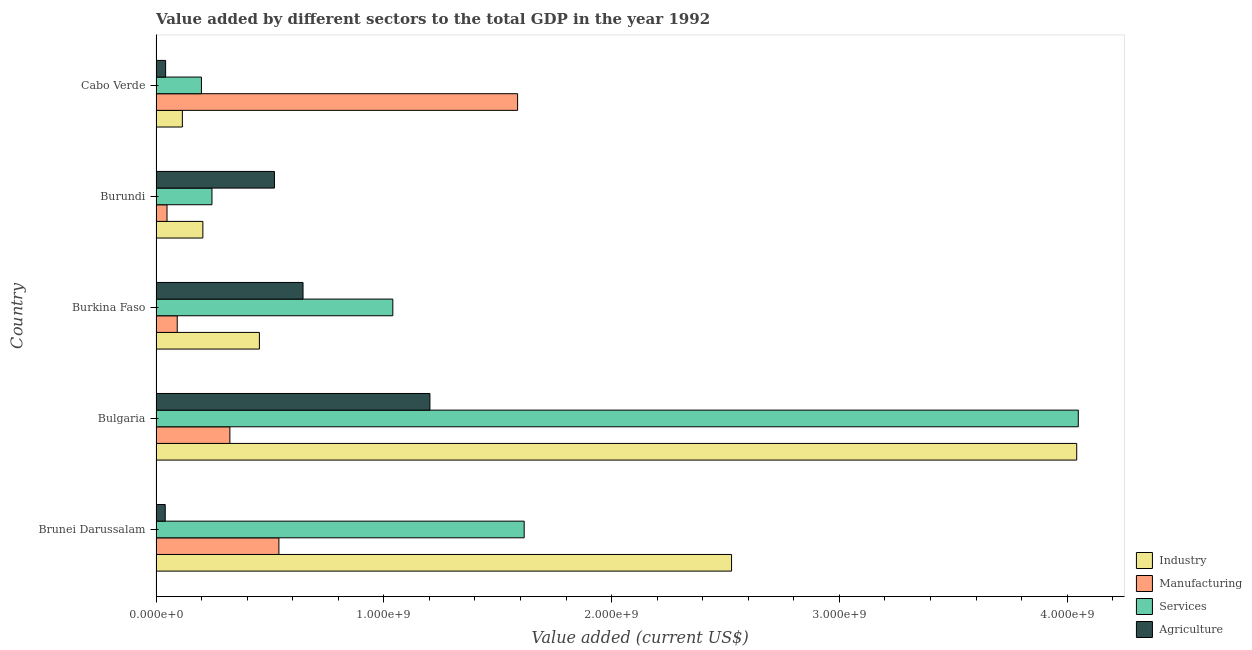Are the number of bars per tick equal to the number of legend labels?
Offer a terse response. Yes. How many bars are there on the 2nd tick from the top?
Ensure brevity in your answer.  4. What is the label of the 1st group of bars from the top?
Keep it short and to the point. Cabo Verde. In how many cases, is the number of bars for a given country not equal to the number of legend labels?
Your response must be concise. 0. What is the value added by services sector in Burkina Faso?
Ensure brevity in your answer.  1.04e+09. Across all countries, what is the maximum value added by industrial sector?
Your answer should be compact. 4.04e+09. Across all countries, what is the minimum value added by services sector?
Give a very brief answer. 1.99e+08. In which country was the value added by industrial sector maximum?
Provide a succinct answer. Bulgaria. In which country was the value added by industrial sector minimum?
Make the answer very short. Cabo Verde. What is the total value added by industrial sector in the graph?
Offer a terse response. 7.34e+09. What is the difference between the value added by agricultural sector in Bulgaria and that in Burundi?
Keep it short and to the point. 6.83e+08. What is the difference between the value added by services sector in Burundi and the value added by manufacturing sector in Burkina Faso?
Your answer should be compact. 1.53e+08. What is the average value added by manufacturing sector per country?
Your answer should be compact. 5.19e+08. What is the difference between the value added by services sector and value added by agricultural sector in Burundi?
Offer a terse response. -2.74e+08. What is the ratio of the value added by agricultural sector in Bulgaria to that in Burkina Faso?
Your answer should be very brief. 1.86. What is the difference between the highest and the second highest value added by agricultural sector?
Make the answer very short. 5.57e+08. What is the difference between the highest and the lowest value added by services sector?
Your response must be concise. 3.85e+09. Is the sum of the value added by industrial sector in Bulgaria and Cabo Verde greater than the maximum value added by agricultural sector across all countries?
Provide a succinct answer. Yes. What does the 4th bar from the top in Brunei Darussalam represents?
Provide a short and direct response. Industry. What does the 3rd bar from the bottom in Burkina Faso represents?
Your answer should be compact. Services. Are all the bars in the graph horizontal?
Your answer should be compact. Yes. What is the difference between two consecutive major ticks on the X-axis?
Your response must be concise. 1.00e+09. Does the graph contain any zero values?
Ensure brevity in your answer.  No. Where does the legend appear in the graph?
Keep it short and to the point. Bottom right. How many legend labels are there?
Your answer should be very brief. 4. How are the legend labels stacked?
Provide a short and direct response. Vertical. What is the title of the graph?
Provide a succinct answer. Value added by different sectors to the total GDP in the year 1992. What is the label or title of the X-axis?
Keep it short and to the point. Value added (current US$). What is the label or title of the Y-axis?
Your answer should be compact. Country. What is the Value added (current US$) of Industry in Brunei Darussalam?
Provide a succinct answer. 2.53e+09. What is the Value added (current US$) of Manufacturing in Brunei Darussalam?
Give a very brief answer. 5.39e+08. What is the Value added (current US$) in Services in Brunei Darussalam?
Give a very brief answer. 1.62e+09. What is the Value added (current US$) of Agriculture in Brunei Darussalam?
Your answer should be very brief. 4.04e+07. What is the Value added (current US$) in Industry in Bulgaria?
Your response must be concise. 4.04e+09. What is the Value added (current US$) of Manufacturing in Bulgaria?
Offer a very short reply. 3.24e+08. What is the Value added (current US$) of Services in Bulgaria?
Offer a terse response. 4.05e+09. What is the Value added (current US$) of Agriculture in Bulgaria?
Offer a very short reply. 1.20e+09. What is the Value added (current US$) in Industry in Burkina Faso?
Ensure brevity in your answer.  4.54e+08. What is the Value added (current US$) of Manufacturing in Burkina Faso?
Keep it short and to the point. 9.31e+07. What is the Value added (current US$) in Services in Burkina Faso?
Give a very brief answer. 1.04e+09. What is the Value added (current US$) of Agriculture in Burkina Faso?
Offer a very short reply. 6.45e+08. What is the Value added (current US$) of Industry in Burundi?
Give a very brief answer. 2.06e+08. What is the Value added (current US$) in Manufacturing in Burundi?
Keep it short and to the point. 4.82e+07. What is the Value added (current US$) of Services in Burundi?
Your response must be concise. 2.46e+08. What is the Value added (current US$) in Agriculture in Burundi?
Give a very brief answer. 5.20e+08. What is the Value added (current US$) of Industry in Cabo Verde?
Provide a short and direct response. 1.16e+08. What is the Value added (current US$) in Manufacturing in Cabo Verde?
Keep it short and to the point. 1.59e+09. What is the Value added (current US$) in Services in Cabo Verde?
Your response must be concise. 1.99e+08. What is the Value added (current US$) in Agriculture in Cabo Verde?
Provide a short and direct response. 4.21e+07. Across all countries, what is the maximum Value added (current US$) in Industry?
Provide a short and direct response. 4.04e+09. Across all countries, what is the maximum Value added (current US$) of Manufacturing?
Give a very brief answer. 1.59e+09. Across all countries, what is the maximum Value added (current US$) in Services?
Provide a succinct answer. 4.05e+09. Across all countries, what is the maximum Value added (current US$) in Agriculture?
Ensure brevity in your answer.  1.20e+09. Across all countries, what is the minimum Value added (current US$) of Industry?
Give a very brief answer. 1.16e+08. Across all countries, what is the minimum Value added (current US$) of Manufacturing?
Ensure brevity in your answer.  4.82e+07. Across all countries, what is the minimum Value added (current US$) of Services?
Keep it short and to the point. 1.99e+08. Across all countries, what is the minimum Value added (current US$) in Agriculture?
Keep it short and to the point. 4.04e+07. What is the total Value added (current US$) of Industry in the graph?
Offer a terse response. 7.34e+09. What is the total Value added (current US$) of Manufacturing in the graph?
Make the answer very short. 2.59e+09. What is the total Value added (current US$) of Services in the graph?
Provide a short and direct response. 7.15e+09. What is the total Value added (current US$) in Agriculture in the graph?
Make the answer very short. 2.45e+09. What is the difference between the Value added (current US$) in Industry in Brunei Darussalam and that in Bulgaria?
Ensure brevity in your answer.  -1.52e+09. What is the difference between the Value added (current US$) of Manufacturing in Brunei Darussalam and that in Bulgaria?
Keep it short and to the point. 2.15e+08. What is the difference between the Value added (current US$) of Services in Brunei Darussalam and that in Bulgaria?
Keep it short and to the point. -2.43e+09. What is the difference between the Value added (current US$) of Agriculture in Brunei Darussalam and that in Bulgaria?
Your answer should be compact. -1.16e+09. What is the difference between the Value added (current US$) of Industry in Brunei Darussalam and that in Burkina Faso?
Give a very brief answer. 2.07e+09. What is the difference between the Value added (current US$) in Manufacturing in Brunei Darussalam and that in Burkina Faso?
Provide a succinct answer. 4.46e+08. What is the difference between the Value added (current US$) in Services in Brunei Darussalam and that in Burkina Faso?
Offer a terse response. 5.77e+08. What is the difference between the Value added (current US$) of Agriculture in Brunei Darussalam and that in Burkina Faso?
Ensure brevity in your answer.  -6.05e+08. What is the difference between the Value added (current US$) in Industry in Brunei Darussalam and that in Burundi?
Offer a very short reply. 2.32e+09. What is the difference between the Value added (current US$) in Manufacturing in Brunei Darussalam and that in Burundi?
Give a very brief answer. 4.91e+08. What is the difference between the Value added (current US$) in Services in Brunei Darussalam and that in Burundi?
Your answer should be compact. 1.37e+09. What is the difference between the Value added (current US$) in Agriculture in Brunei Darussalam and that in Burundi?
Your answer should be very brief. -4.80e+08. What is the difference between the Value added (current US$) in Industry in Brunei Darussalam and that in Cabo Verde?
Offer a very short reply. 2.41e+09. What is the difference between the Value added (current US$) in Manufacturing in Brunei Darussalam and that in Cabo Verde?
Your answer should be very brief. -1.05e+09. What is the difference between the Value added (current US$) in Services in Brunei Darussalam and that in Cabo Verde?
Offer a very short reply. 1.42e+09. What is the difference between the Value added (current US$) in Agriculture in Brunei Darussalam and that in Cabo Verde?
Your answer should be very brief. -1.74e+06. What is the difference between the Value added (current US$) in Industry in Bulgaria and that in Burkina Faso?
Provide a succinct answer. 3.59e+09. What is the difference between the Value added (current US$) of Manufacturing in Bulgaria and that in Burkina Faso?
Keep it short and to the point. 2.31e+08. What is the difference between the Value added (current US$) of Services in Bulgaria and that in Burkina Faso?
Offer a terse response. 3.01e+09. What is the difference between the Value added (current US$) in Agriculture in Bulgaria and that in Burkina Faso?
Your answer should be compact. 5.57e+08. What is the difference between the Value added (current US$) in Industry in Bulgaria and that in Burundi?
Provide a succinct answer. 3.84e+09. What is the difference between the Value added (current US$) of Manufacturing in Bulgaria and that in Burundi?
Your answer should be compact. 2.76e+08. What is the difference between the Value added (current US$) of Services in Bulgaria and that in Burundi?
Provide a short and direct response. 3.80e+09. What is the difference between the Value added (current US$) of Agriculture in Bulgaria and that in Burundi?
Your answer should be very brief. 6.83e+08. What is the difference between the Value added (current US$) in Industry in Bulgaria and that in Cabo Verde?
Your answer should be compact. 3.93e+09. What is the difference between the Value added (current US$) in Manufacturing in Bulgaria and that in Cabo Verde?
Your answer should be very brief. -1.26e+09. What is the difference between the Value added (current US$) in Services in Bulgaria and that in Cabo Verde?
Offer a very short reply. 3.85e+09. What is the difference between the Value added (current US$) of Agriculture in Bulgaria and that in Cabo Verde?
Offer a terse response. 1.16e+09. What is the difference between the Value added (current US$) in Industry in Burkina Faso and that in Burundi?
Give a very brief answer. 2.48e+08. What is the difference between the Value added (current US$) of Manufacturing in Burkina Faso and that in Burundi?
Provide a succinct answer. 4.49e+07. What is the difference between the Value added (current US$) of Services in Burkina Faso and that in Burundi?
Keep it short and to the point. 7.94e+08. What is the difference between the Value added (current US$) in Agriculture in Burkina Faso and that in Burundi?
Offer a terse response. 1.26e+08. What is the difference between the Value added (current US$) of Industry in Burkina Faso and that in Cabo Verde?
Make the answer very short. 3.38e+08. What is the difference between the Value added (current US$) of Manufacturing in Burkina Faso and that in Cabo Verde?
Provide a short and direct response. -1.49e+09. What is the difference between the Value added (current US$) of Services in Burkina Faso and that in Cabo Verde?
Your answer should be very brief. 8.40e+08. What is the difference between the Value added (current US$) of Agriculture in Burkina Faso and that in Cabo Verde?
Make the answer very short. 6.03e+08. What is the difference between the Value added (current US$) in Industry in Burundi and that in Cabo Verde?
Make the answer very short. 9.00e+07. What is the difference between the Value added (current US$) of Manufacturing in Burundi and that in Cabo Verde?
Your answer should be very brief. -1.54e+09. What is the difference between the Value added (current US$) of Services in Burundi and that in Cabo Verde?
Your answer should be very brief. 4.63e+07. What is the difference between the Value added (current US$) of Agriculture in Burundi and that in Cabo Verde?
Keep it short and to the point. 4.78e+08. What is the difference between the Value added (current US$) in Industry in Brunei Darussalam and the Value added (current US$) in Manufacturing in Bulgaria?
Your answer should be compact. 2.20e+09. What is the difference between the Value added (current US$) in Industry in Brunei Darussalam and the Value added (current US$) in Services in Bulgaria?
Keep it short and to the point. -1.52e+09. What is the difference between the Value added (current US$) of Industry in Brunei Darussalam and the Value added (current US$) of Agriculture in Bulgaria?
Make the answer very short. 1.32e+09. What is the difference between the Value added (current US$) in Manufacturing in Brunei Darussalam and the Value added (current US$) in Services in Bulgaria?
Offer a terse response. -3.51e+09. What is the difference between the Value added (current US$) of Manufacturing in Brunei Darussalam and the Value added (current US$) of Agriculture in Bulgaria?
Your answer should be very brief. -6.63e+08. What is the difference between the Value added (current US$) in Services in Brunei Darussalam and the Value added (current US$) in Agriculture in Bulgaria?
Provide a succinct answer. 4.14e+08. What is the difference between the Value added (current US$) in Industry in Brunei Darussalam and the Value added (current US$) in Manufacturing in Burkina Faso?
Offer a terse response. 2.43e+09. What is the difference between the Value added (current US$) in Industry in Brunei Darussalam and the Value added (current US$) in Services in Burkina Faso?
Offer a very short reply. 1.49e+09. What is the difference between the Value added (current US$) in Industry in Brunei Darussalam and the Value added (current US$) in Agriculture in Burkina Faso?
Provide a succinct answer. 1.88e+09. What is the difference between the Value added (current US$) of Manufacturing in Brunei Darussalam and the Value added (current US$) of Services in Burkina Faso?
Your response must be concise. -5.00e+08. What is the difference between the Value added (current US$) of Manufacturing in Brunei Darussalam and the Value added (current US$) of Agriculture in Burkina Faso?
Offer a terse response. -1.06e+08. What is the difference between the Value added (current US$) of Services in Brunei Darussalam and the Value added (current US$) of Agriculture in Burkina Faso?
Your response must be concise. 9.71e+08. What is the difference between the Value added (current US$) in Industry in Brunei Darussalam and the Value added (current US$) in Manufacturing in Burundi?
Keep it short and to the point. 2.48e+09. What is the difference between the Value added (current US$) in Industry in Brunei Darussalam and the Value added (current US$) in Services in Burundi?
Provide a short and direct response. 2.28e+09. What is the difference between the Value added (current US$) of Industry in Brunei Darussalam and the Value added (current US$) of Agriculture in Burundi?
Ensure brevity in your answer.  2.01e+09. What is the difference between the Value added (current US$) in Manufacturing in Brunei Darussalam and the Value added (current US$) in Services in Burundi?
Make the answer very short. 2.94e+08. What is the difference between the Value added (current US$) of Manufacturing in Brunei Darussalam and the Value added (current US$) of Agriculture in Burundi?
Provide a short and direct response. 1.96e+07. What is the difference between the Value added (current US$) in Services in Brunei Darussalam and the Value added (current US$) in Agriculture in Burundi?
Your answer should be compact. 1.10e+09. What is the difference between the Value added (current US$) of Industry in Brunei Darussalam and the Value added (current US$) of Manufacturing in Cabo Verde?
Your answer should be very brief. 9.39e+08. What is the difference between the Value added (current US$) in Industry in Brunei Darussalam and the Value added (current US$) in Services in Cabo Verde?
Keep it short and to the point. 2.33e+09. What is the difference between the Value added (current US$) of Industry in Brunei Darussalam and the Value added (current US$) of Agriculture in Cabo Verde?
Provide a succinct answer. 2.48e+09. What is the difference between the Value added (current US$) of Manufacturing in Brunei Darussalam and the Value added (current US$) of Services in Cabo Verde?
Your response must be concise. 3.40e+08. What is the difference between the Value added (current US$) of Manufacturing in Brunei Darussalam and the Value added (current US$) of Agriculture in Cabo Verde?
Provide a short and direct response. 4.97e+08. What is the difference between the Value added (current US$) of Services in Brunei Darussalam and the Value added (current US$) of Agriculture in Cabo Verde?
Your response must be concise. 1.57e+09. What is the difference between the Value added (current US$) in Industry in Bulgaria and the Value added (current US$) in Manufacturing in Burkina Faso?
Your answer should be compact. 3.95e+09. What is the difference between the Value added (current US$) in Industry in Bulgaria and the Value added (current US$) in Services in Burkina Faso?
Keep it short and to the point. 3.00e+09. What is the difference between the Value added (current US$) in Industry in Bulgaria and the Value added (current US$) in Agriculture in Burkina Faso?
Keep it short and to the point. 3.40e+09. What is the difference between the Value added (current US$) in Manufacturing in Bulgaria and the Value added (current US$) in Services in Burkina Faso?
Your answer should be very brief. -7.15e+08. What is the difference between the Value added (current US$) of Manufacturing in Bulgaria and the Value added (current US$) of Agriculture in Burkina Faso?
Offer a very short reply. -3.21e+08. What is the difference between the Value added (current US$) in Services in Bulgaria and the Value added (current US$) in Agriculture in Burkina Faso?
Give a very brief answer. 3.40e+09. What is the difference between the Value added (current US$) of Industry in Bulgaria and the Value added (current US$) of Manufacturing in Burundi?
Keep it short and to the point. 3.99e+09. What is the difference between the Value added (current US$) of Industry in Bulgaria and the Value added (current US$) of Services in Burundi?
Make the answer very short. 3.80e+09. What is the difference between the Value added (current US$) of Industry in Bulgaria and the Value added (current US$) of Agriculture in Burundi?
Make the answer very short. 3.52e+09. What is the difference between the Value added (current US$) in Manufacturing in Bulgaria and the Value added (current US$) in Services in Burundi?
Your answer should be very brief. 7.86e+07. What is the difference between the Value added (current US$) in Manufacturing in Bulgaria and the Value added (current US$) in Agriculture in Burundi?
Offer a very short reply. -1.96e+08. What is the difference between the Value added (current US$) of Services in Bulgaria and the Value added (current US$) of Agriculture in Burundi?
Provide a succinct answer. 3.53e+09. What is the difference between the Value added (current US$) in Industry in Bulgaria and the Value added (current US$) in Manufacturing in Cabo Verde?
Offer a terse response. 2.45e+09. What is the difference between the Value added (current US$) in Industry in Bulgaria and the Value added (current US$) in Services in Cabo Verde?
Offer a terse response. 3.84e+09. What is the difference between the Value added (current US$) in Industry in Bulgaria and the Value added (current US$) in Agriculture in Cabo Verde?
Your answer should be very brief. 4.00e+09. What is the difference between the Value added (current US$) in Manufacturing in Bulgaria and the Value added (current US$) in Services in Cabo Verde?
Keep it short and to the point. 1.25e+08. What is the difference between the Value added (current US$) in Manufacturing in Bulgaria and the Value added (current US$) in Agriculture in Cabo Verde?
Offer a very short reply. 2.82e+08. What is the difference between the Value added (current US$) in Services in Bulgaria and the Value added (current US$) in Agriculture in Cabo Verde?
Offer a very short reply. 4.01e+09. What is the difference between the Value added (current US$) in Industry in Burkina Faso and the Value added (current US$) in Manufacturing in Burundi?
Give a very brief answer. 4.06e+08. What is the difference between the Value added (current US$) in Industry in Burkina Faso and the Value added (current US$) in Services in Burundi?
Provide a succinct answer. 2.08e+08. What is the difference between the Value added (current US$) in Industry in Burkina Faso and the Value added (current US$) in Agriculture in Burundi?
Offer a very short reply. -6.60e+07. What is the difference between the Value added (current US$) of Manufacturing in Burkina Faso and the Value added (current US$) of Services in Burundi?
Your answer should be compact. -1.53e+08. What is the difference between the Value added (current US$) in Manufacturing in Burkina Faso and the Value added (current US$) in Agriculture in Burundi?
Provide a succinct answer. -4.27e+08. What is the difference between the Value added (current US$) of Services in Burkina Faso and the Value added (current US$) of Agriculture in Burundi?
Keep it short and to the point. 5.20e+08. What is the difference between the Value added (current US$) of Industry in Burkina Faso and the Value added (current US$) of Manufacturing in Cabo Verde?
Your response must be concise. -1.13e+09. What is the difference between the Value added (current US$) of Industry in Burkina Faso and the Value added (current US$) of Services in Cabo Verde?
Ensure brevity in your answer.  2.54e+08. What is the difference between the Value added (current US$) of Industry in Burkina Faso and the Value added (current US$) of Agriculture in Cabo Verde?
Your answer should be very brief. 4.12e+08. What is the difference between the Value added (current US$) in Manufacturing in Burkina Faso and the Value added (current US$) in Services in Cabo Verde?
Your response must be concise. -1.06e+08. What is the difference between the Value added (current US$) of Manufacturing in Burkina Faso and the Value added (current US$) of Agriculture in Cabo Verde?
Offer a terse response. 5.10e+07. What is the difference between the Value added (current US$) in Services in Burkina Faso and the Value added (current US$) in Agriculture in Cabo Verde?
Provide a succinct answer. 9.98e+08. What is the difference between the Value added (current US$) in Industry in Burundi and the Value added (current US$) in Manufacturing in Cabo Verde?
Your answer should be compact. -1.38e+09. What is the difference between the Value added (current US$) of Industry in Burundi and the Value added (current US$) of Services in Cabo Verde?
Offer a terse response. 6.24e+06. What is the difference between the Value added (current US$) of Industry in Burundi and the Value added (current US$) of Agriculture in Cabo Verde?
Ensure brevity in your answer.  1.64e+08. What is the difference between the Value added (current US$) of Manufacturing in Burundi and the Value added (current US$) of Services in Cabo Verde?
Your answer should be very brief. -1.51e+08. What is the difference between the Value added (current US$) of Manufacturing in Burundi and the Value added (current US$) of Agriculture in Cabo Verde?
Offer a very short reply. 6.11e+06. What is the difference between the Value added (current US$) in Services in Burundi and the Value added (current US$) in Agriculture in Cabo Verde?
Make the answer very short. 2.04e+08. What is the average Value added (current US$) of Industry per country?
Make the answer very short. 1.47e+09. What is the average Value added (current US$) of Manufacturing per country?
Ensure brevity in your answer.  5.19e+08. What is the average Value added (current US$) of Services per country?
Your answer should be compact. 1.43e+09. What is the average Value added (current US$) in Agriculture per country?
Give a very brief answer. 4.90e+08. What is the difference between the Value added (current US$) in Industry and Value added (current US$) in Manufacturing in Brunei Darussalam?
Provide a short and direct response. 1.99e+09. What is the difference between the Value added (current US$) in Industry and Value added (current US$) in Services in Brunei Darussalam?
Your answer should be very brief. 9.10e+08. What is the difference between the Value added (current US$) in Industry and Value added (current US$) in Agriculture in Brunei Darussalam?
Your answer should be very brief. 2.49e+09. What is the difference between the Value added (current US$) of Manufacturing and Value added (current US$) of Services in Brunei Darussalam?
Give a very brief answer. -1.08e+09. What is the difference between the Value added (current US$) of Manufacturing and Value added (current US$) of Agriculture in Brunei Darussalam?
Provide a succinct answer. 4.99e+08. What is the difference between the Value added (current US$) of Services and Value added (current US$) of Agriculture in Brunei Darussalam?
Your response must be concise. 1.58e+09. What is the difference between the Value added (current US$) in Industry and Value added (current US$) in Manufacturing in Bulgaria?
Keep it short and to the point. 3.72e+09. What is the difference between the Value added (current US$) in Industry and Value added (current US$) in Services in Bulgaria?
Your response must be concise. -6.96e+06. What is the difference between the Value added (current US$) in Industry and Value added (current US$) in Agriculture in Bulgaria?
Offer a terse response. 2.84e+09. What is the difference between the Value added (current US$) of Manufacturing and Value added (current US$) of Services in Bulgaria?
Ensure brevity in your answer.  -3.72e+09. What is the difference between the Value added (current US$) in Manufacturing and Value added (current US$) in Agriculture in Bulgaria?
Your response must be concise. -8.78e+08. What is the difference between the Value added (current US$) of Services and Value added (current US$) of Agriculture in Bulgaria?
Your answer should be very brief. 2.85e+09. What is the difference between the Value added (current US$) of Industry and Value added (current US$) of Manufacturing in Burkina Faso?
Give a very brief answer. 3.61e+08. What is the difference between the Value added (current US$) in Industry and Value added (current US$) in Services in Burkina Faso?
Your response must be concise. -5.86e+08. What is the difference between the Value added (current US$) in Industry and Value added (current US$) in Agriculture in Burkina Faso?
Your response must be concise. -1.92e+08. What is the difference between the Value added (current US$) of Manufacturing and Value added (current US$) of Services in Burkina Faso?
Provide a succinct answer. -9.46e+08. What is the difference between the Value added (current US$) in Manufacturing and Value added (current US$) in Agriculture in Burkina Faso?
Give a very brief answer. -5.52e+08. What is the difference between the Value added (current US$) in Services and Value added (current US$) in Agriculture in Burkina Faso?
Ensure brevity in your answer.  3.94e+08. What is the difference between the Value added (current US$) in Industry and Value added (current US$) in Manufacturing in Burundi?
Give a very brief answer. 1.57e+08. What is the difference between the Value added (current US$) in Industry and Value added (current US$) in Services in Burundi?
Make the answer very short. -4.00e+07. What is the difference between the Value added (current US$) in Industry and Value added (current US$) in Agriculture in Burundi?
Your answer should be compact. -3.14e+08. What is the difference between the Value added (current US$) of Manufacturing and Value added (current US$) of Services in Burundi?
Provide a succinct answer. -1.97e+08. What is the difference between the Value added (current US$) of Manufacturing and Value added (current US$) of Agriculture in Burundi?
Your answer should be very brief. -4.72e+08. What is the difference between the Value added (current US$) of Services and Value added (current US$) of Agriculture in Burundi?
Ensure brevity in your answer.  -2.74e+08. What is the difference between the Value added (current US$) in Industry and Value added (current US$) in Manufacturing in Cabo Verde?
Your answer should be compact. -1.47e+09. What is the difference between the Value added (current US$) in Industry and Value added (current US$) in Services in Cabo Verde?
Your answer should be compact. -8.37e+07. What is the difference between the Value added (current US$) in Industry and Value added (current US$) in Agriculture in Cabo Verde?
Offer a very short reply. 7.35e+07. What is the difference between the Value added (current US$) in Manufacturing and Value added (current US$) in Services in Cabo Verde?
Your answer should be compact. 1.39e+09. What is the difference between the Value added (current US$) of Manufacturing and Value added (current US$) of Agriculture in Cabo Verde?
Keep it short and to the point. 1.55e+09. What is the difference between the Value added (current US$) of Services and Value added (current US$) of Agriculture in Cabo Verde?
Offer a very short reply. 1.57e+08. What is the ratio of the Value added (current US$) of Industry in Brunei Darussalam to that in Bulgaria?
Offer a terse response. 0.63. What is the ratio of the Value added (current US$) of Manufacturing in Brunei Darussalam to that in Bulgaria?
Offer a terse response. 1.66. What is the ratio of the Value added (current US$) in Services in Brunei Darussalam to that in Bulgaria?
Your answer should be compact. 0.4. What is the ratio of the Value added (current US$) of Agriculture in Brunei Darussalam to that in Bulgaria?
Provide a succinct answer. 0.03. What is the ratio of the Value added (current US$) of Industry in Brunei Darussalam to that in Burkina Faso?
Your response must be concise. 5.57. What is the ratio of the Value added (current US$) of Manufacturing in Brunei Darussalam to that in Burkina Faso?
Provide a short and direct response. 5.79. What is the ratio of the Value added (current US$) of Services in Brunei Darussalam to that in Burkina Faso?
Offer a very short reply. 1.55. What is the ratio of the Value added (current US$) of Agriculture in Brunei Darussalam to that in Burkina Faso?
Ensure brevity in your answer.  0.06. What is the ratio of the Value added (current US$) in Industry in Brunei Darussalam to that in Burundi?
Keep it short and to the point. 12.29. What is the ratio of the Value added (current US$) of Manufacturing in Brunei Darussalam to that in Burundi?
Provide a succinct answer. 11.19. What is the ratio of the Value added (current US$) of Services in Brunei Darussalam to that in Burundi?
Your answer should be compact. 6.58. What is the ratio of the Value added (current US$) in Agriculture in Brunei Darussalam to that in Burundi?
Your answer should be very brief. 0.08. What is the ratio of the Value added (current US$) of Industry in Brunei Darussalam to that in Cabo Verde?
Keep it short and to the point. 21.85. What is the ratio of the Value added (current US$) of Manufacturing in Brunei Darussalam to that in Cabo Verde?
Your response must be concise. 0.34. What is the ratio of the Value added (current US$) of Services in Brunei Darussalam to that in Cabo Verde?
Your response must be concise. 8.11. What is the ratio of the Value added (current US$) of Agriculture in Brunei Darussalam to that in Cabo Verde?
Your response must be concise. 0.96. What is the ratio of the Value added (current US$) in Industry in Bulgaria to that in Burkina Faso?
Provide a short and direct response. 8.91. What is the ratio of the Value added (current US$) in Manufacturing in Bulgaria to that in Burkina Faso?
Keep it short and to the point. 3.48. What is the ratio of the Value added (current US$) in Services in Bulgaria to that in Burkina Faso?
Give a very brief answer. 3.89. What is the ratio of the Value added (current US$) of Agriculture in Bulgaria to that in Burkina Faso?
Ensure brevity in your answer.  1.86. What is the ratio of the Value added (current US$) of Industry in Bulgaria to that in Burundi?
Give a very brief answer. 19.66. What is the ratio of the Value added (current US$) in Manufacturing in Bulgaria to that in Burundi?
Offer a very short reply. 6.72. What is the ratio of the Value added (current US$) in Services in Bulgaria to that in Burundi?
Keep it short and to the point. 16.48. What is the ratio of the Value added (current US$) of Agriculture in Bulgaria to that in Burundi?
Your answer should be compact. 2.31. What is the ratio of the Value added (current US$) of Industry in Bulgaria to that in Cabo Verde?
Ensure brevity in your answer.  34.95. What is the ratio of the Value added (current US$) in Manufacturing in Bulgaria to that in Cabo Verde?
Your response must be concise. 0.2. What is the ratio of the Value added (current US$) of Services in Bulgaria to that in Cabo Verde?
Your answer should be very brief. 20.31. What is the ratio of the Value added (current US$) in Agriculture in Bulgaria to that in Cabo Verde?
Your response must be concise. 28.55. What is the ratio of the Value added (current US$) of Industry in Burkina Faso to that in Burundi?
Provide a short and direct response. 2.21. What is the ratio of the Value added (current US$) in Manufacturing in Burkina Faso to that in Burundi?
Your response must be concise. 1.93. What is the ratio of the Value added (current US$) in Services in Burkina Faso to that in Burundi?
Offer a terse response. 4.23. What is the ratio of the Value added (current US$) in Agriculture in Burkina Faso to that in Burundi?
Provide a succinct answer. 1.24. What is the ratio of the Value added (current US$) of Industry in Burkina Faso to that in Cabo Verde?
Offer a terse response. 3.92. What is the ratio of the Value added (current US$) of Manufacturing in Burkina Faso to that in Cabo Verde?
Keep it short and to the point. 0.06. What is the ratio of the Value added (current US$) of Services in Burkina Faso to that in Cabo Verde?
Ensure brevity in your answer.  5.21. What is the ratio of the Value added (current US$) of Agriculture in Burkina Faso to that in Cabo Verde?
Provide a succinct answer. 15.32. What is the ratio of the Value added (current US$) in Industry in Burundi to that in Cabo Verde?
Make the answer very short. 1.78. What is the ratio of the Value added (current US$) of Manufacturing in Burundi to that in Cabo Verde?
Provide a short and direct response. 0.03. What is the ratio of the Value added (current US$) in Services in Burundi to that in Cabo Verde?
Provide a succinct answer. 1.23. What is the ratio of the Value added (current US$) of Agriculture in Burundi to that in Cabo Verde?
Your answer should be compact. 12.34. What is the difference between the highest and the second highest Value added (current US$) in Industry?
Your response must be concise. 1.52e+09. What is the difference between the highest and the second highest Value added (current US$) of Manufacturing?
Provide a succinct answer. 1.05e+09. What is the difference between the highest and the second highest Value added (current US$) of Services?
Your answer should be compact. 2.43e+09. What is the difference between the highest and the second highest Value added (current US$) of Agriculture?
Keep it short and to the point. 5.57e+08. What is the difference between the highest and the lowest Value added (current US$) of Industry?
Your answer should be compact. 3.93e+09. What is the difference between the highest and the lowest Value added (current US$) in Manufacturing?
Make the answer very short. 1.54e+09. What is the difference between the highest and the lowest Value added (current US$) of Services?
Ensure brevity in your answer.  3.85e+09. What is the difference between the highest and the lowest Value added (current US$) of Agriculture?
Provide a succinct answer. 1.16e+09. 